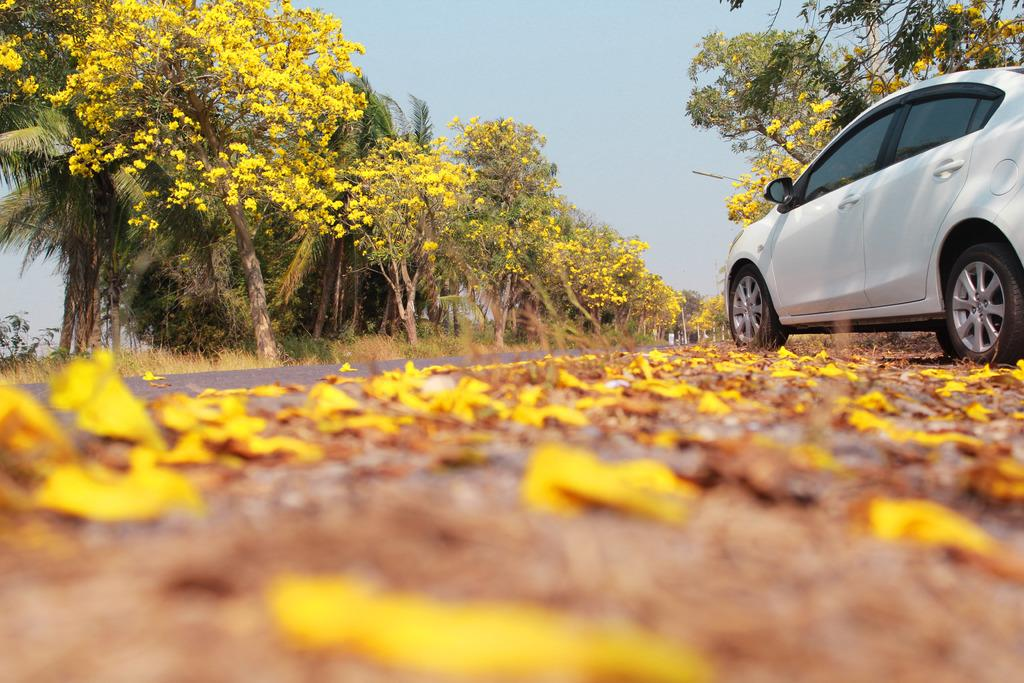What is the main subject of the image? There is a car in the image. What can be seen in the background of the image? There are trees and flowers in the background of the image. What is covering the road at the bottom of the image? The road is covered with petals and leaves at the bottom of the image. What is visible at the top of the image? The sky is visible at the top of the image. How many family members are visible in the image? There is no family present in the image; it only features a car, trees, flowers, petals, leaves, and the sky. What type of bed is visible in the image? There is no bed present in the image. 